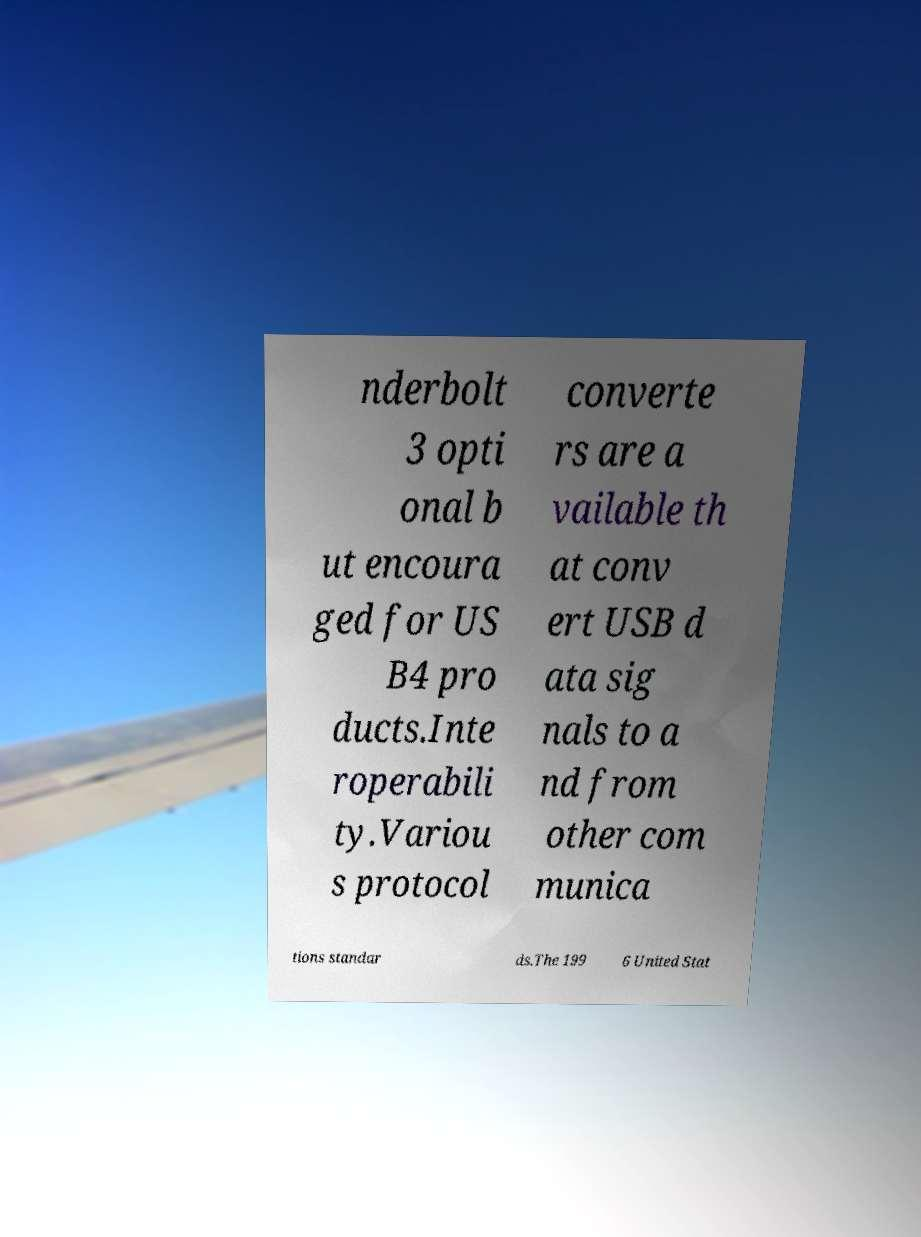I need the written content from this picture converted into text. Can you do that? nderbolt 3 opti onal b ut encoura ged for US B4 pro ducts.Inte roperabili ty.Variou s protocol converte rs are a vailable th at conv ert USB d ata sig nals to a nd from other com munica tions standar ds.The 199 6 United Stat 